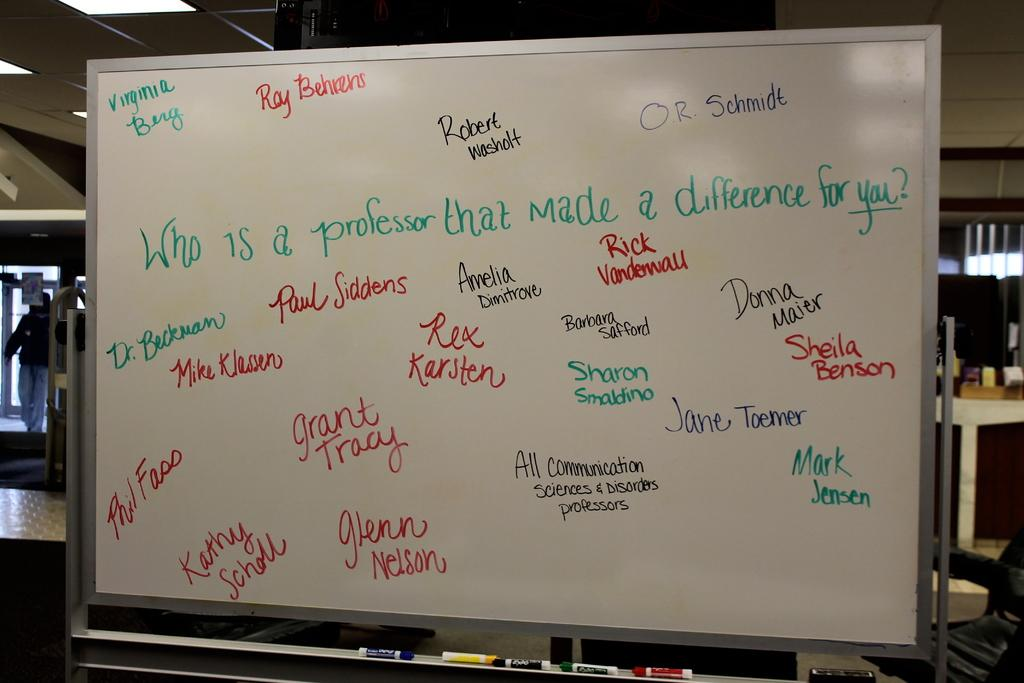<image>
Summarize the visual content of the image. the word Rex that is on a board 